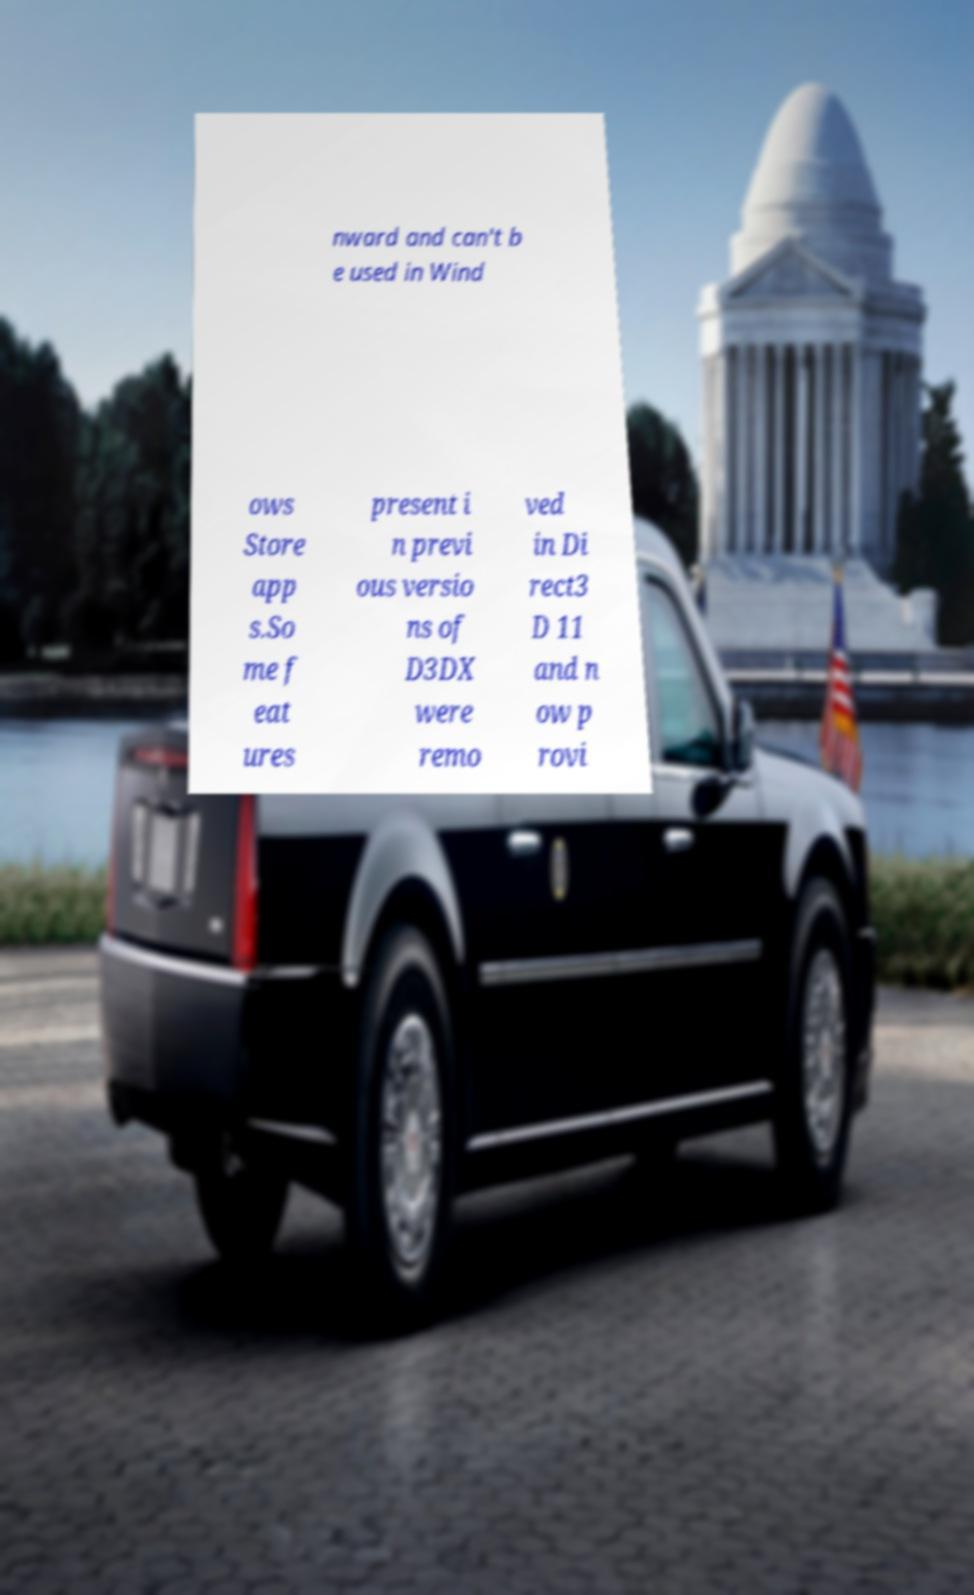Can you read and provide the text displayed in the image?This photo seems to have some interesting text. Can you extract and type it out for me? nward and can't b e used in Wind ows Store app s.So me f eat ures present i n previ ous versio ns of D3DX were remo ved in Di rect3 D 11 and n ow p rovi 